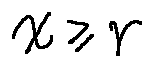Convert formula to latex. <formula><loc_0><loc_0><loc_500><loc_500>x \geq r</formula> 